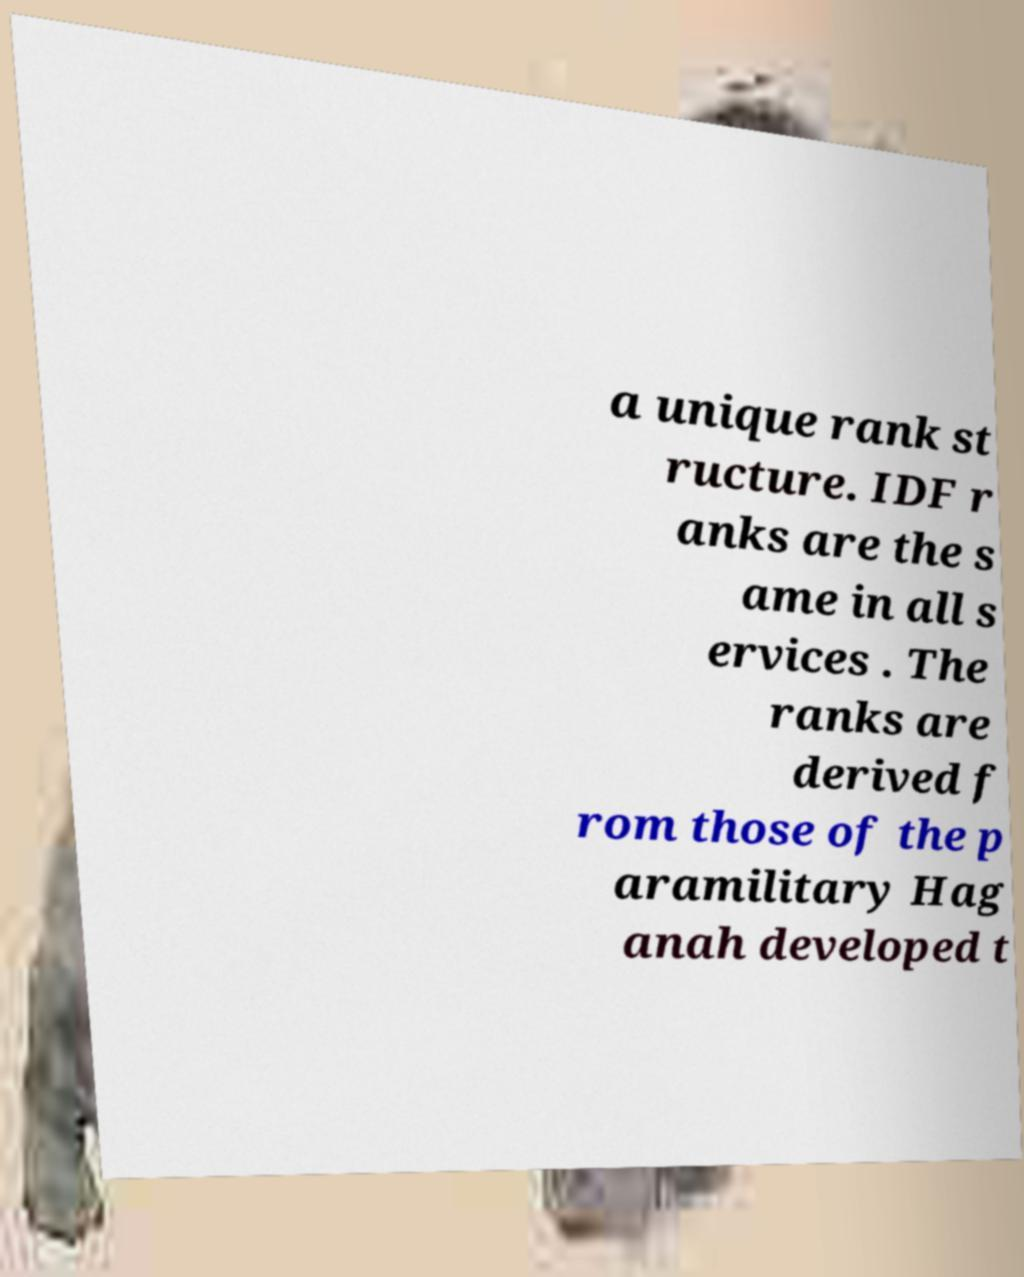Please read and relay the text visible in this image. What does it say? a unique rank st ructure. IDF r anks are the s ame in all s ervices . The ranks are derived f rom those of the p aramilitary Hag anah developed t 